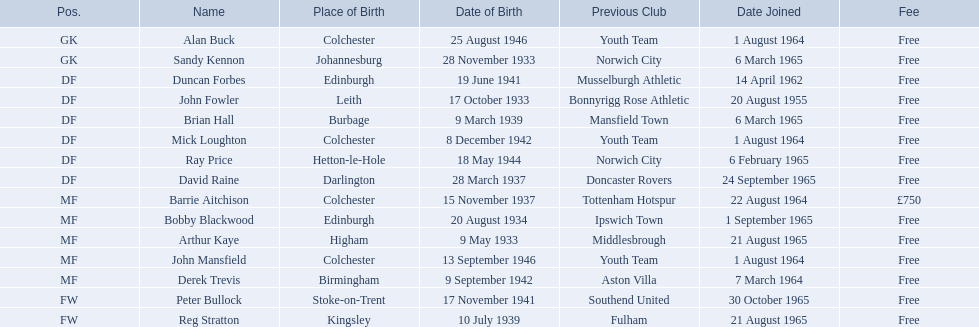During the 1965-66 season, when was alan buck's joining date for colchester united f.c.? 1 August 1964. When was the last player's joining date in the same season? Peter Bullock. What was the date when the first player joined? 20 August 1955. 